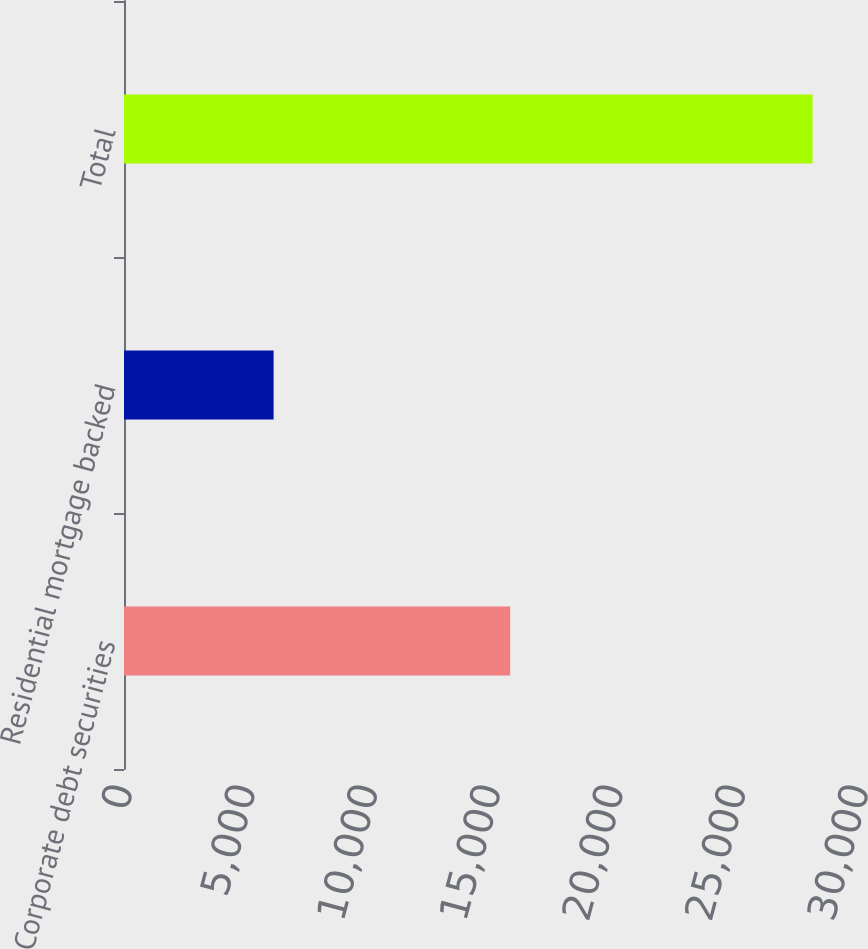Convert chart. <chart><loc_0><loc_0><loc_500><loc_500><bar_chart><fcel>Corporate debt securities<fcel>Residential mortgage backed<fcel>Total<nl><fcel>15742<fcel>6099<fcel>28066<nl></chart> 